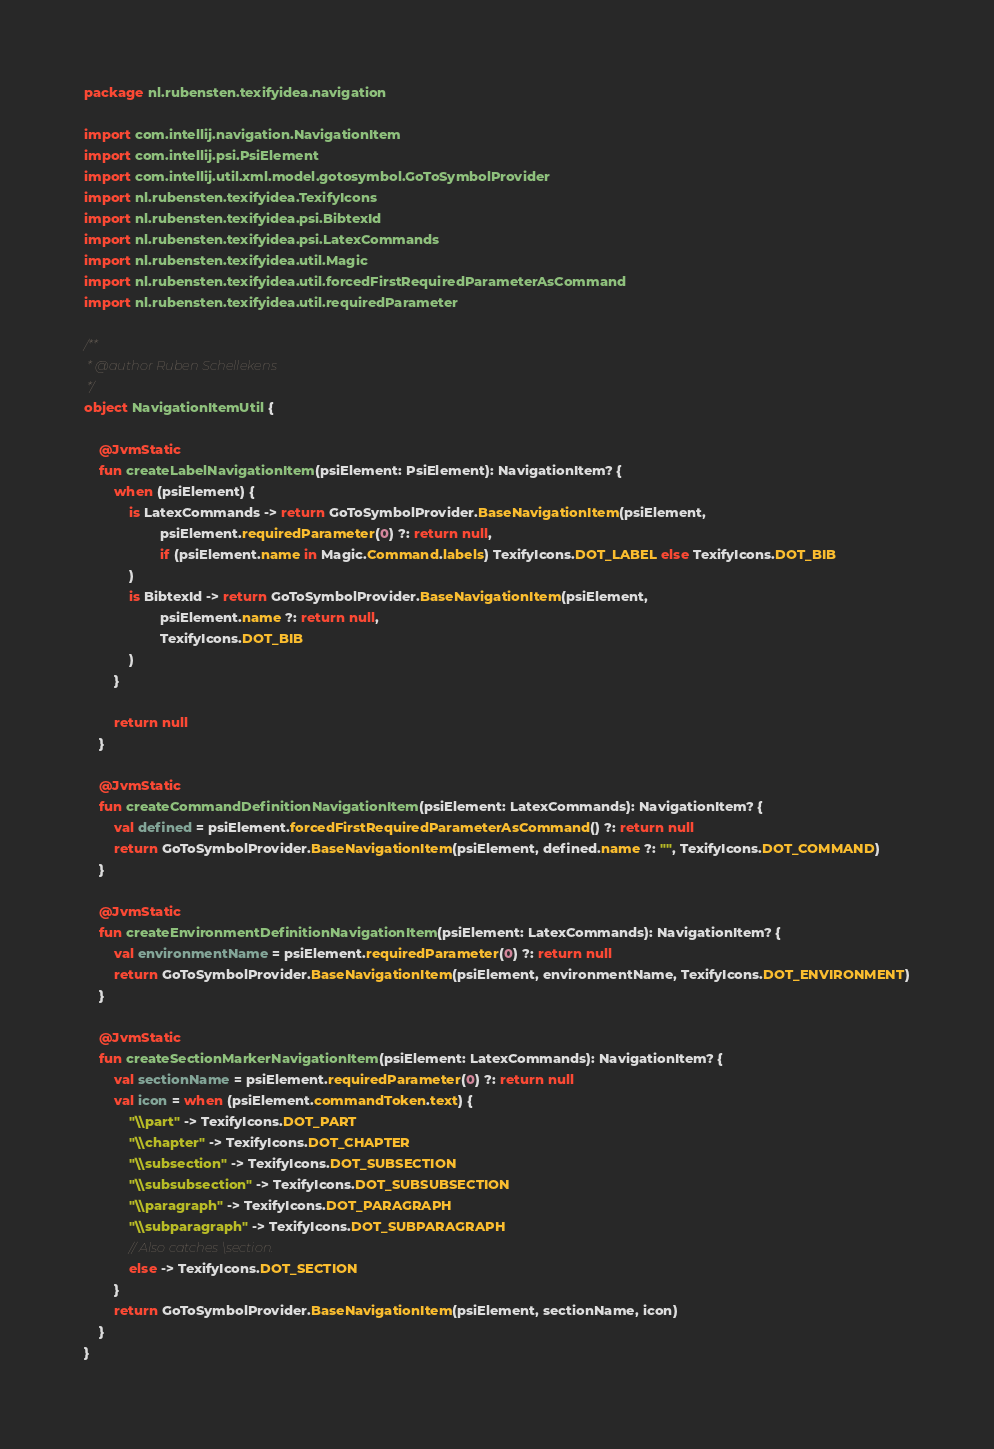Convert code to text. <code><loc_0><loc_0><loc_500><loc_500><_Kotlin_>package nl.rubensten.texifyidea.navigation

import com.intellij.navigation.NavigationItem
import com.intellij.psi.PsiElement
import com.intellij.util.xml.model.gotosymbol.GoToSymbolProvider
import nl.rubensten.texifyidea.TexifyIcons
import nl.rubensten.texifyidea.psi.BibtexId
import nl.rubensten.texifyidea.psi.LatexCommands
import nl.rubensten.texifyidea.util.Magic
import nl.rubensten.texifyidea.util.forcedFirstRequiredParameterAsCommand
import nl.rubensten.texifyidea.util.requiredParameter

/**
 * @author Ruben Schellekens
 */
object NavigationItemUtil {

    @JvmStatic
    fun createLabelNavigationItem(psiElement: PsiElement): NavigationItem? {
        when (psiElement) {
            is LatexCommands -> return GoToSymbolProvider.BaseNavigationItem(psiElement,
                    psiElement.requiredParameter(0) ?: return null,
                    if (psiElement.name in Magic.Command.labels) TexifyIcons.DOT_LABEL else TexifyIcons.DOT_BIB
            )
            is BibtexId -> return GoToSymbolProvider.BaseNavigationItem(psiElement,
                    psiElement.name ?: return null,
                    TexifyIcons.DOT_BIB
            )
        }

        return null
    }

    @JvmStatic
    fun createCommandDefinitionNavigationItem(psiElement: LatexCommands): NavigationItem? {
        val defined = psiElement.forcedFirstRequiredParameterAsCommand() ?: return null
        return GoToSymbolProvider.BaseNavigationItem(psiElement, defined.name ?: "", TexifyIcons.DOT_COMMAND)
    }

    @JvmStatic
    fun createEnvironmentDefinitionNavigationItem(psiElement: LatexCommands): NavigationItem? {
        val environmentName = psiElement.requiredParameter(0) ?: return null
        return GoToSymbolProvider.BaseNavigationItem(psiElement, environmentName, TexifyIcons.DOT_ENVIRONMENT)
    }

    @JvmStatic
    fun createSectionMarkerNavigationItem(psiElement: LatexCommands): NavigationItem? {
        val sectionName = psiElement.requiredParameter(0) ?: return null
        val icon = when (psiElement.commandToken.text) {
            "\\part" -> TexifyIcons.DOT_PART
            "\\chapter" -> TexifyIcons.DOT_CHAPTER
            "\\subsection" -> TexifyIcons.DOT_SUBSECTION
            "\\subsubsection" -> TexifyIcons.DOT_SUBSUBSECTION
            "\\paragraph" -> TexifyIcons.DOT_PARAGRAPH
            "\\subparagraph" -> TexifyIcons.DOT_SUBPARAGRAPH
            // Also catches \section.
            else -> TexifyIcons.DOT_SECTION
        }
        return GoToSymbolProvider.BaseNavigationItem(psiElement, sectionName, icon)
    }
}</code> 